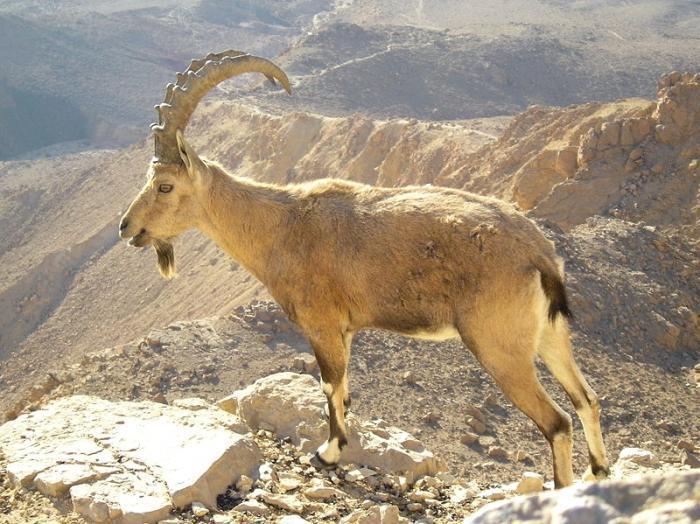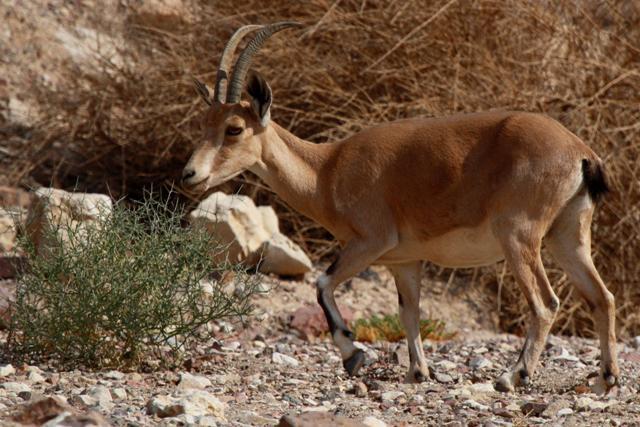The first image is the image on the left, the second image is the image on the right. Evaluate the accuracy of this statement regarding the images: "There are several goats visible in each set; much more than two.". Is it true? Answer yes or no. No. The first image is the image on the left, the second image is the image on the right. Given the left and right images, does the statement "At least one big horn sheep is looking down over the edge of a tall cliff." hold true? Answer yes or no. Yes. 